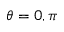<formula> <loc_0><loc_0><loc_500><loc_500>\theta = 0 , \pi</formula> 